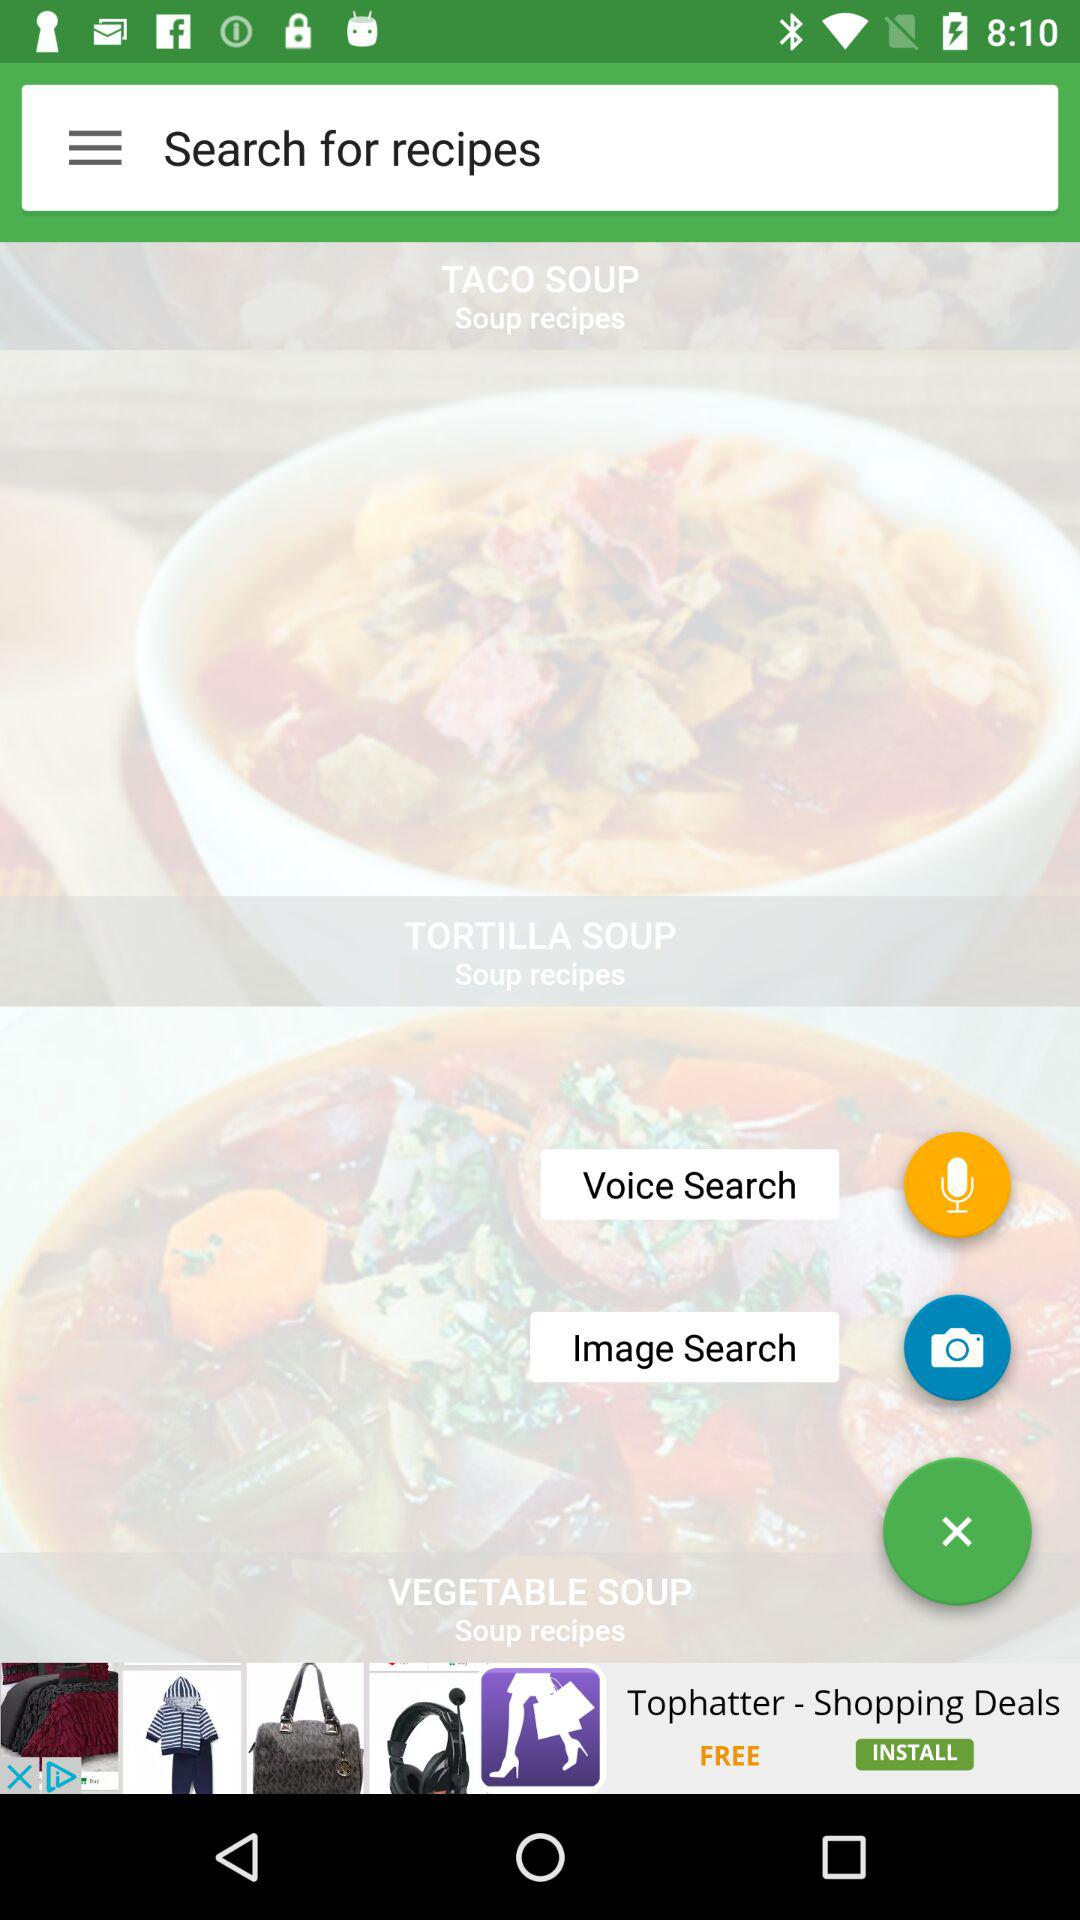How many search options are there?
Answer the question using a single word or phrase. 3 